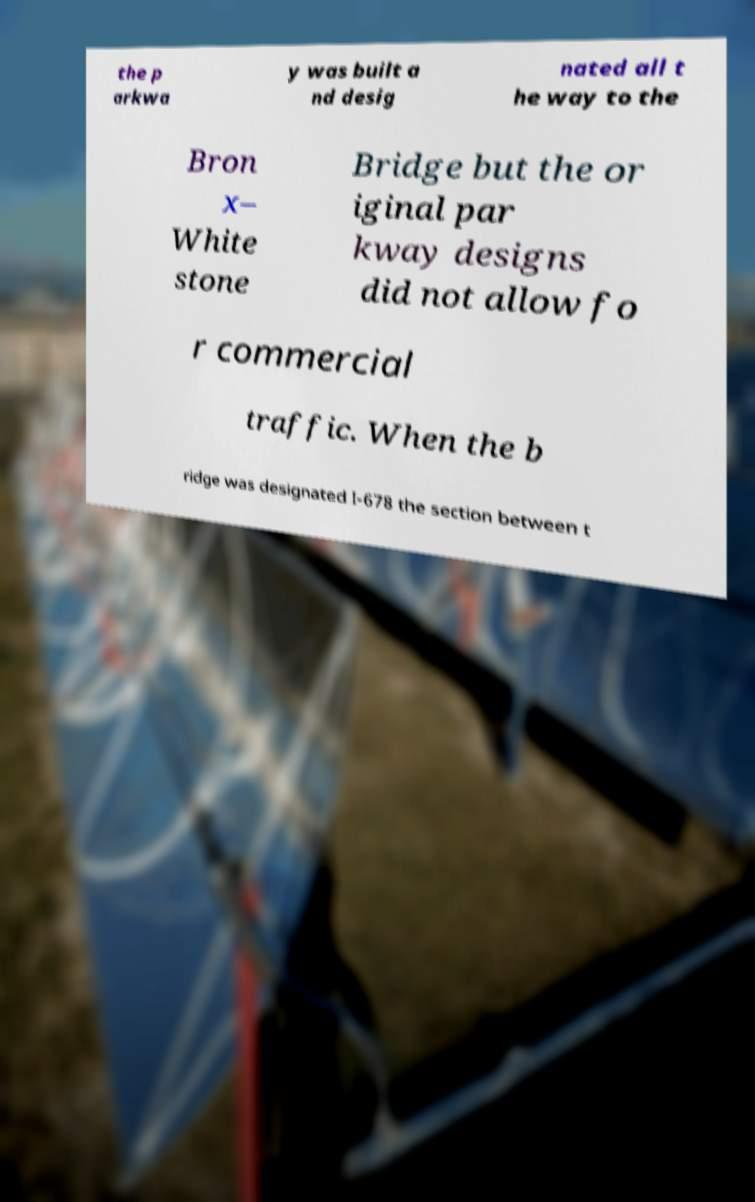Can you read and provide the text displayed in the image?This photo seems to have some interesting text. Can you extract and type it out for me? the p arkwa y was built a nd desig nated all t he way to the Bron x– White stone Bridge but the or iginal par kway designs did not allow fo r commercial traffic. When the b ridge was designated I-678 the section between t 